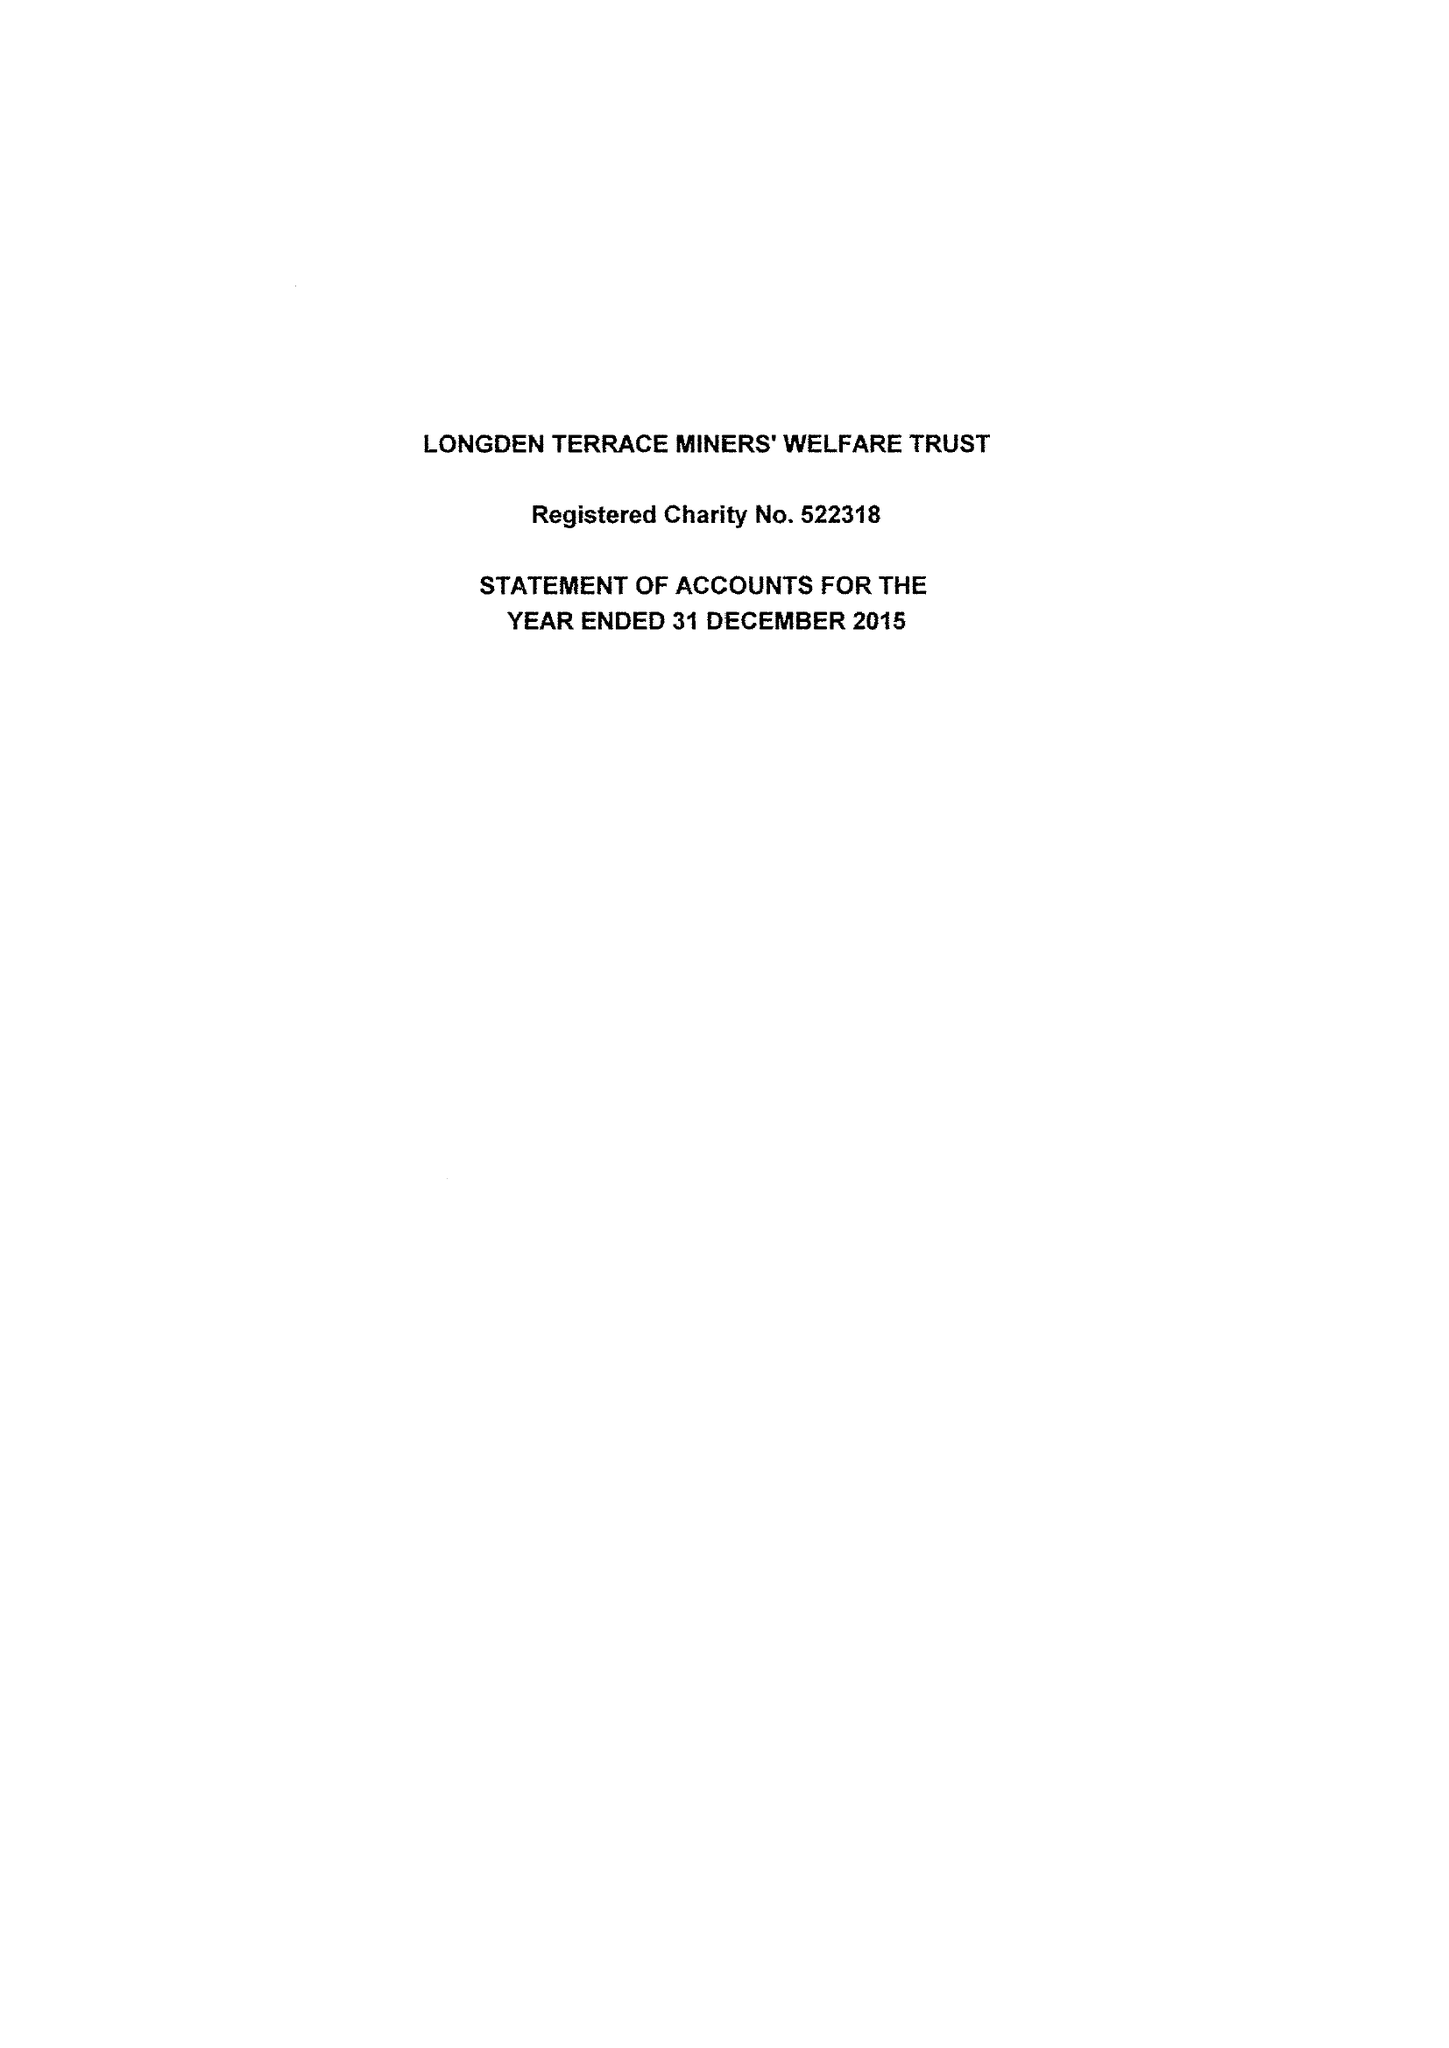What is the value for the charity_number?
Answer the question using a single word or phrase. 522318 